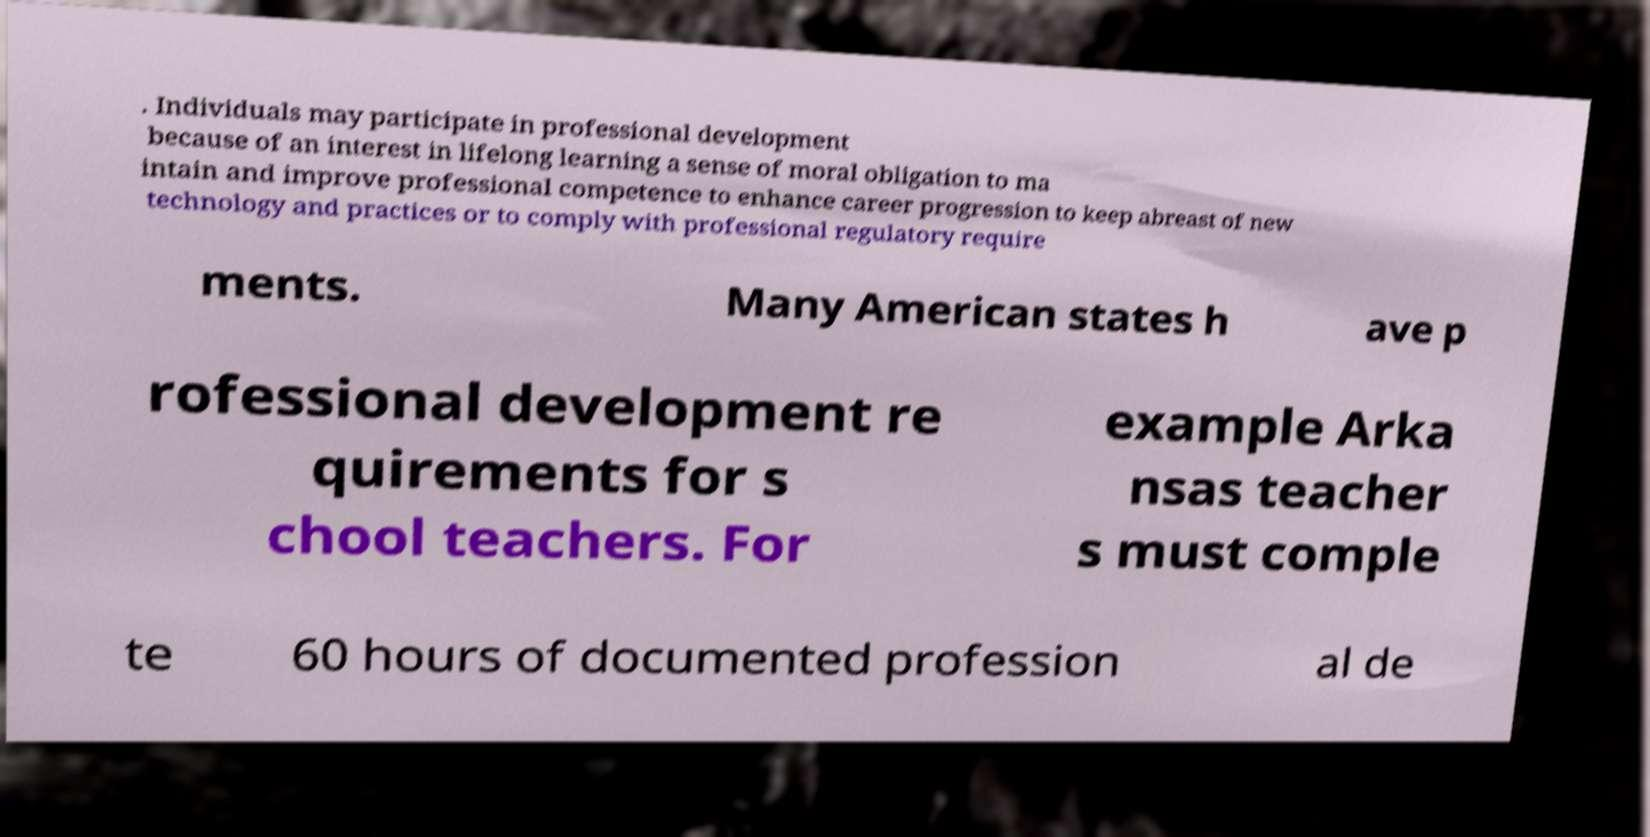Please read and relay the text visible in this image. What does it say? . Individuals may participate in professional development because of an interest in lifelong learning a sense of moral obligation to ma intain and improve professional competence to enhance career progression to keep abreast of new technology and practices or to comply with professional regulatory require ments. Many American states h ave p rofessional development re quirements for s chool teachers. For example Arka nsas teacher s must comple te 60 hours of documented profession al de 